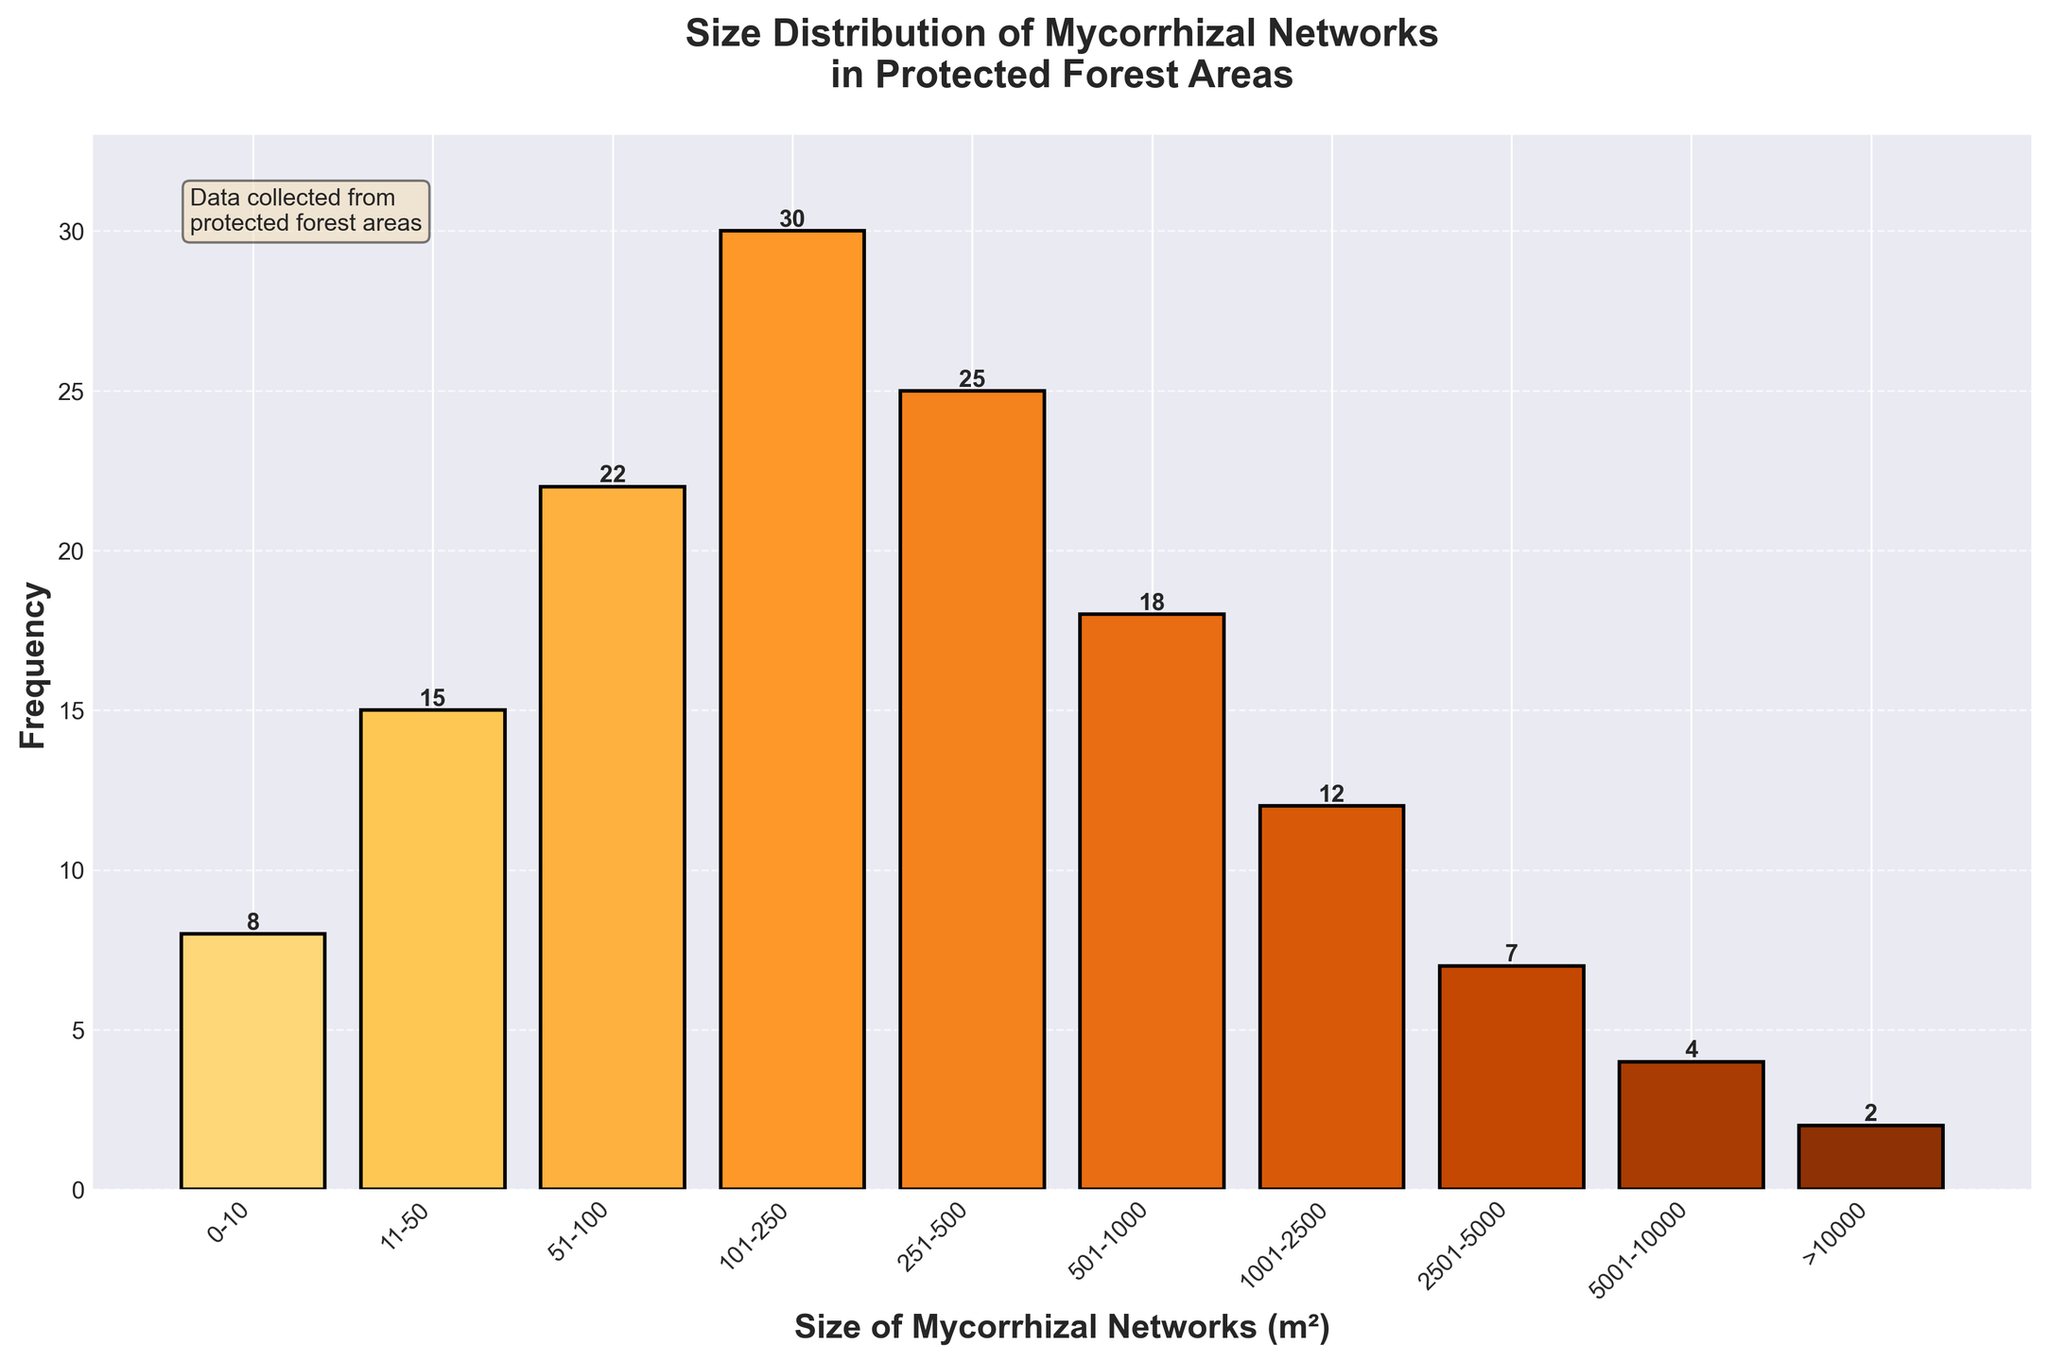What is the title of the plot? The title is shown at the top of the plot, and it summarizes what the plot is depicting. The title is "Size Distribution of Mycorrhizal Networks in Protected Forest Areas."
Answer: Size Distribution of Mycorrhizal Networks in Protected Forest Areas How many size categories are displayed in the histogram? By counting the distinct categories on the x-axis, we can see that there are 10 size categories represented.
Answer: 10 Which size category has the highest frequency of mycorrhizal networks? By comparing the heights of all bars in the histogram, the category with the highest bar represents the highest frequency. The tallest bar corresponds to the 101-250 m² size category.
Answer: 101-250 m² What is the frequency of mycorrhizal networks in the 501-1000 m² size category? Looking at the height of the bar labeled 501-1000 m² on the x-axis, the number on top of it shows the frequency. The bar for the 501-1000 m² size category has a frequency of 18.
Answer: 18 What is the combined frequency of mycorrhizal networks in the smallest two size categories? To find the combined frequency, we need to add the frequencies of the 0-10 m² and 11-50 m² categories. The frequencies are 8 and 15 respectively, so 8 + 15 = 23.
Answer: 23 How many mycorrhizal networks have sizes greater than 1000 m²? To determine this, sum the frequencies of all bars representing sizes greater than 1000 m² (1001-2500, 2501-5000, 5001-10000, and >10000). These frequencies are 12, 7, 4, and 2 respectively. So, 12 + 7 + 4 + 2 = 25.
Answer: 25 What is the difference in frequency between the 101-250 m² and the >10000 m² size categories? Subtract the frequency of the >10000 m² category from that of the 101-250 m² category. The frequencies are 30 and 2 respectively, so 30 - 2 = 28.
Answer: 28 Which size category has the lowest frequency of mycorrhizal networks? By comparing the heights of the bars, the shortest bar corresponds to the size category with the lowest frequency. The >10000 m² size category has the lowest frequency.
Answer: >10000 m² What is the average frequency of mycorrhizal networks across all size categories? To find the average frequency, sum all the frequencies and divide by the number of categories. The sum is 8 + 15 + 22 + 30 + 25 + 18 + 12 + 7 + 4 + 2 = 143. There are 10 categories, so the average frequency is 143 / 10 = 14.3.
Answer: 14.3 